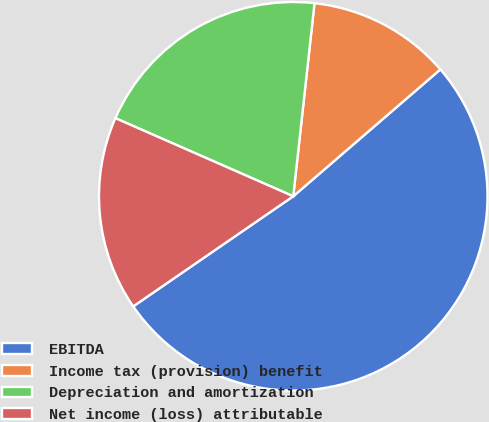Convert chart to OTSL. <chart><loc_0><loc_0><loc_500><loc_500><pie_chart><fcel>EBITDA<fcel>Income tax (provision) benefit<fcel>Depreciation and amortization<fcel>Net income (loss) attributable<nl><fcel>51.74%<fcel>11.93%<fcel>20.16%<fcel>16.18%<nl></chart> 